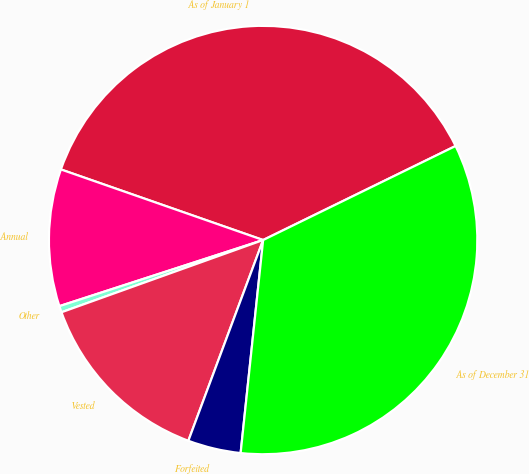Convert chart. <chart><loc_0><loc_0><loc_500><loc_500><pie_chart><fcel>As of January 1<fcel>Annual<fcel>Other<fcel>Vested<fcel>Forfeited<fcel>As of December 31<nl><fcel>37.42%<fcel>10.34%<fcel>0.48%<fcel>13.85%<fcel>4.0%<fcel>33.91%<nl></chart> 